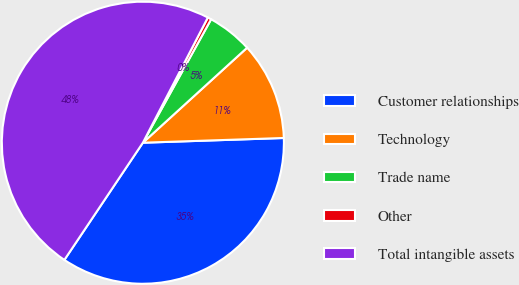Convert chart. <chart><loc_0><loc_0><loc_500><loc_500><pie_chart><fcel>Customer relationships<fcel>Technology<fcel>Trade name<fcel>Other<fcel>Total intangible assets<nl><fcel>34.93%<fcel>11.23%<fcel>5.2%<fcel>0.42%<fcel>48.23%<nl></chart> 